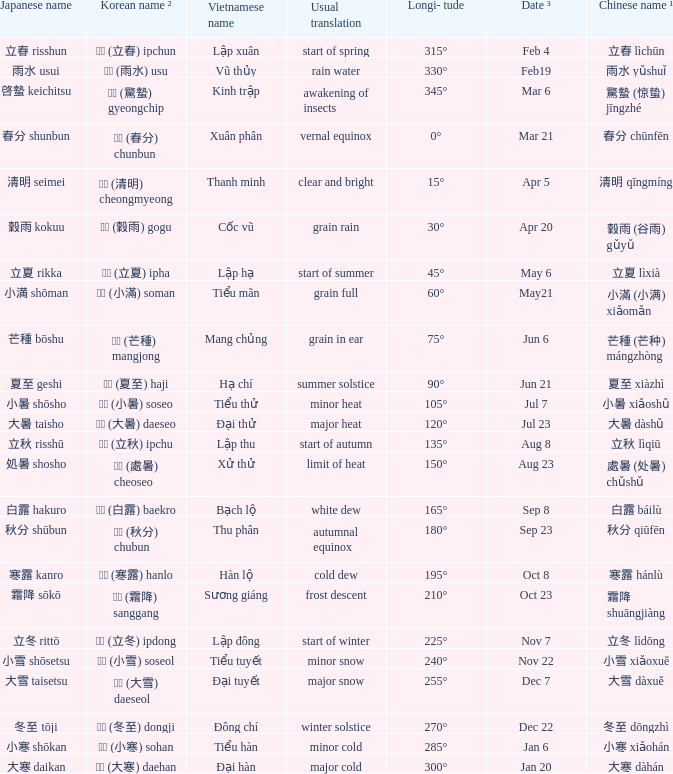WHICH Vietnamese name has a Chinese name ¹ of 芒種 (芒种) mángzhòng? Mang chủng. 